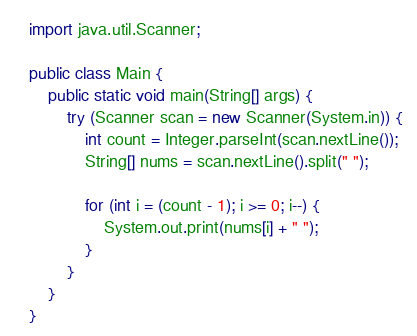<code> <loc_0><loc_0><loc_500><loc_500><_Java_>import java.util.Scanner;

public class Main {
    public static void main(String[] args) {
        try (Scanner scan = new Scanner(System.in)) {
            int count = Integer.parseInt(scan.nextLine());
            String[] nums = scan.nextLine().split(" ");

            for (int i = (count - 1); i >= 0; i--) {
                System.out.print(nums[i] + " ");
            }
        }
    }
}

</code> 